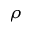Convert formula to latex. <formula><loc_0><loc_0><loc_500><loc_500>\rho</formula> 